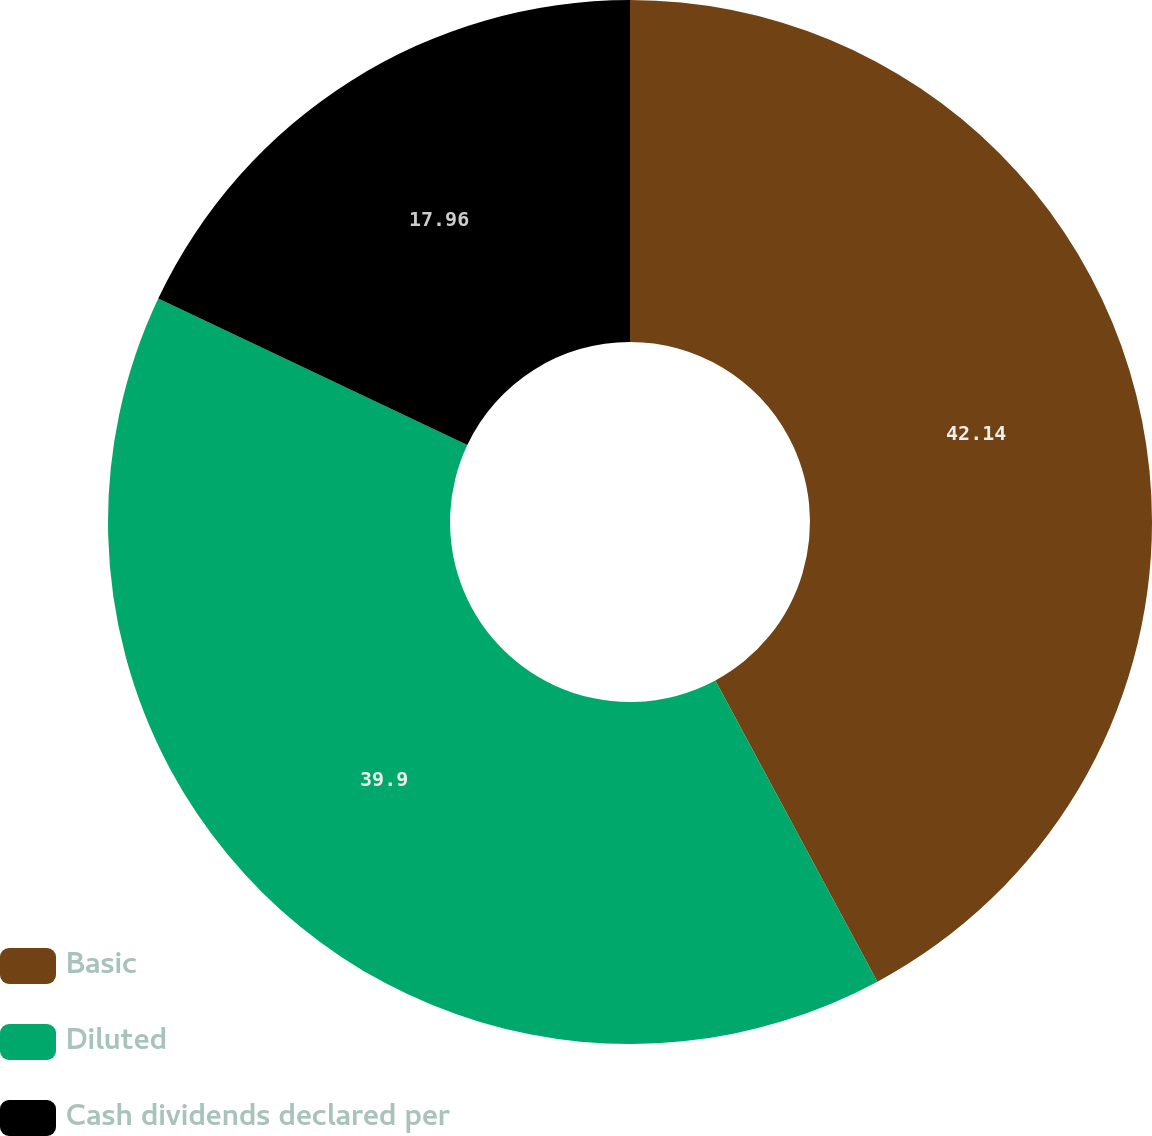Convert chart. <chart><loc_0><loc_0><loc_500><loc_500><pie_chart><fcel>Basic<fcel>Diluted<fcel>Cash dividends declared per<nl><fcel>42.14%<fcel>39.9%<fcel>17.96%<nl></chart> 